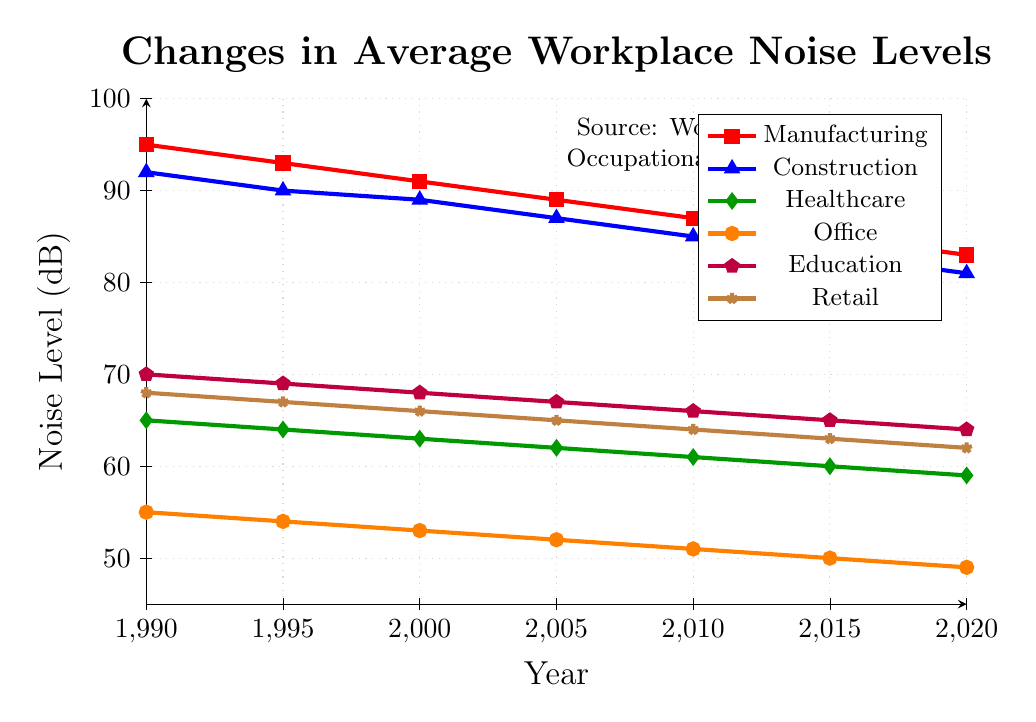What is the trend of noise levels in the manufacturing sector from 1990 to 2020? Observe the line corresponding to the manufacturing sector (red with square markers). The noise levels decreased consistently from 95 dB in 1990 to 83 dB in 2020.
Answer: Decreasing Which sector had the highest average noise level in 2000? Compare the noise levels of all sectors in the year 2000. The manufacturing sector had the highest value (91 dB).
Answer: Manufacturing By how much did the noise level in the construction sector decrease from 1990 to 2020? Look at the construction sector’s noise levels in 1990 (92 dB) and 2020 (81 dB). Subtract 81 from 92.
Answer: 11 dB Between the healthcare and retail sectors, which had higher noise levels in 2015? Compare the values for healthcare (60 dB) and retail (63 dB) in 2015. Retail is higher.
Answer: Retail Which sector shows the smallest reduction in noise levels from 1990 to 2020? Calculate the reduction for each sector by subtracting the 1990 value from the 2020 value. The healthcare sector decreased by 6 dB (65 to 59), which is the smallest among all sectors.
Answer: Healthcare What is the average noise level across all sectors in the year 2010? Sum the noise levels of all sectors in 2010 and divide by the number of sectors (87+85+61+51+66+64)/6.
Answer: 69 dB In which year did the education sector reach a noise level of 64 dB? Look at the noise levels for the education sector and find the year when it was 64 dB. This occurred in 2020.
Answer: 2020 Which sector showed the largest decrease in noise levels from 1990 to 2020? Calculate the reduction for each sector by subtracting the 2020 value from the 1990 value. The manufacturing sector decreased by 12 dB (95 to 83), which is the largest reduction.
Answer: Manufacturing Are the noise levels in the office sector higher or lower than retail in 2015? Compare the values for the office sector (50 dB) and retail sector (63 dB) in 2015. The office sector is lower.
Answer: Lower What is the total reduction in noise levels from 1990 to 2020 for the office and retail sectors combined? Calculate the reduction for each sector (office: 55-49 = 6 dB, retail: 68-62 = 6 dB), then sum the reductions (6 + 6).
Answer: 12 dB 